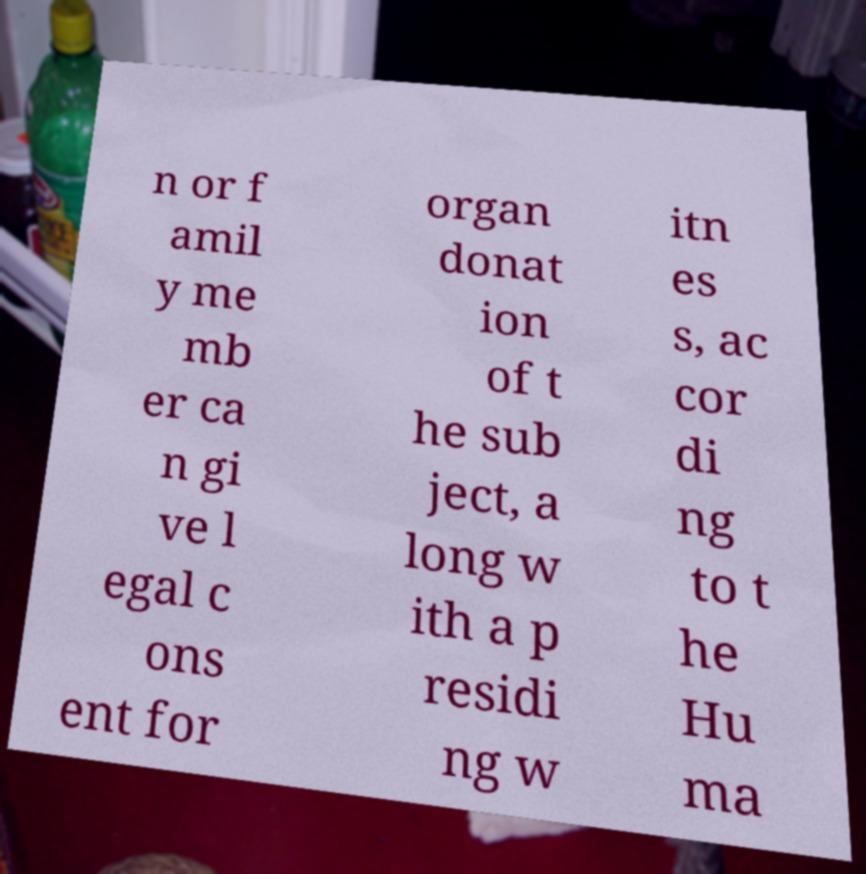For documentation purposes, I need the text within this image transcribed. Could you provide that? n or f amil y me mb er ca n gi ve l egal c ons ent for organ donat ion of t he sub ject, a long w ith a p residi ng w itn es s, ac cor di ng to t he Hu ma 